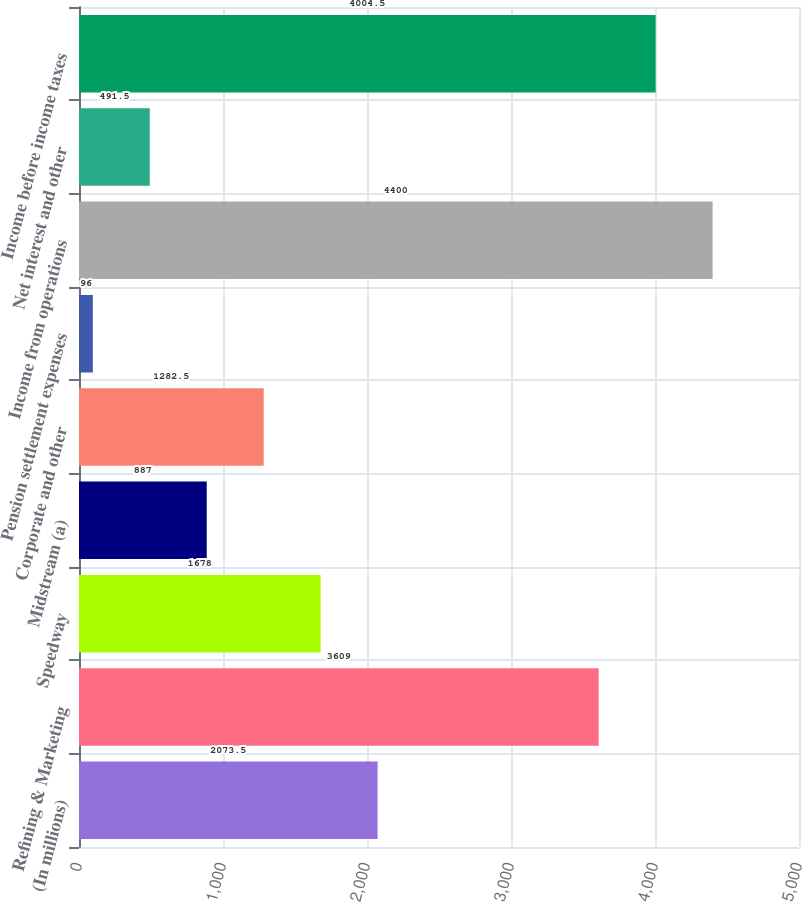Convert chart. <chart><loc_0><loc_0><loc_500><loc_500><bar_chart><fcel>(In millions)<fcel>Refining & Marketing<fcel>Speedway<fcel>Midstream (a)<fcel>Corporate and other<fcel>Pension settlement expenses<fcel>Income from operations<fcel>Net interest and other<fcel>Income before income taxes<nl><fcel>2073.5<fcel>3609<fcel>1678<fcel>887<fcel>1282.5<fcel>96<fcel>4400<fcel>491.5<fcel>4004.5<nl></chart> 